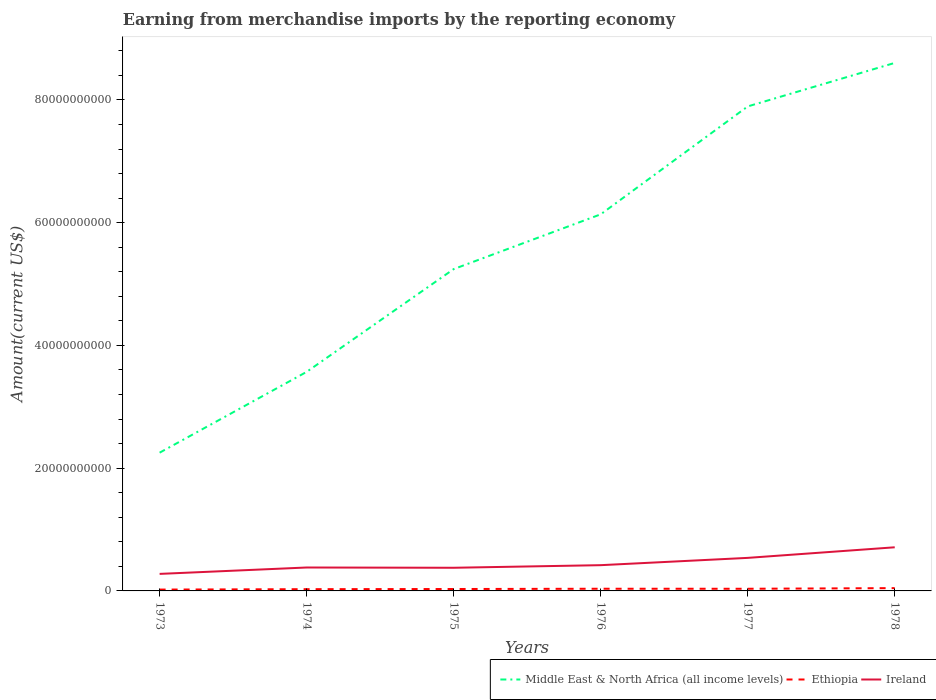Across all years, what is the maximum amount earned from merchandise imports in Ireland?
Your answer should be very brief. 2.78e+09. What is the total amount earned from merchandise imports in Ethiopia in the graph?
Give a very brief answer. -2.67e+07. What is the difference between the highest and the second highest amount earned from merchandise imports in Ethiopia?
Offer a very short reply. 2.37e+08. What is the difference between the highest and the lowest amount earned from merchandise imports in Middle East & North Africa (all income levels)?
Ensure brevity in your answer.  3. Are the values on the major ticks of Y-axis written in scientific E-notation?
Offer a terse response. No. Does the graph contain any zero values?
Your answer should be compact. No. Does the graph contain grids?
Give a very brief answer. No. What is the title of the graph?
Ensure brevity in your answer.  Earning from merchandise imports by the reporting economy. What is the label or title of the Y-axis?
Make the answer very short. Amount(current US$). What is the Amount(current US$) of Middle East & North Africa (all income levels) in 1973?
Offer a very short reply. 2.25e+1. What is the Amount(current US$) of Ethiopia in 1973?
Make the answer very short. 2.18e+08. What is the Amount(current US$) in Ireland in 1973?
Your answer should be compact. 2.78e+09. What is the Amount(current US$) in Middle East & North Africa (all income levels) in 1974?
Your response must be concise. 3.57e+1. What is the Amount(current US$) in Ethiopia in 1974?
Offer a very short reply. 2.84e+08. What is the Amount(current US$) of Ireland in 1974?
Your response must be concise. 3.82e+09. What is the Amount(current US$) of Middle East & North Africa (all income levels) in 1975?
Your answer should be very brief. 5.24e+1. What is the Amount(current US$) in Ethiopia in 1975?
Your response must be concise. 3.11e+08. What is the Amount(current US$) of Ireland in 1975?
Provide a short and direct response. 3.77e+09. What is the Amount(current US$) in Middle East & North Africa (all income levels) in 1976?
Provide a succinct answer. 6.14e+1. What is the Amount(current US$) of Ethiopia in 1976?
Your answer should be compact. 3.55e+08. What is the Amount(current US$) in Ireland in 1976?
Offer a terse response. 4.20e+09. What is the Amount(current US$) of Middle East & North Africa (all income levels) in 1977?
Your answer should be compact. 7.89e+1. What is the Amount(current US$) in Ethiopia in 1977?
Your answer should be very brief. 3.52e+08. What is the Amount(current US$) of Ireland in 1977?
Your answer should be very brief. 5.38e+09. What is the Amount(current US$) in Middle East & North Africa (all income levels) in 1978?
Your answer should be compact. 8.60e+1. What is the Amount(current US$) in Ethiopia in 1978?
Provide a short and direct response. 4.55e+08. What is the Amount(current US$) in Ireland in 1978?
Make the answer very short. 7.11e+09. Across all years, what is the maximum Amount(current US$) of Middle East & North Africa (all income levels)?
Your answer should be compact. 8.60e+1. Across all years, what is the maximum Amount(current US$) of Ethiopia?
Your answer should be compact. 4.55e+08. Across all years, what is the maximum Amount(current US$) in Ireland?
Make the answer very short. 7.11e+09. Across all years, what is the minimum Amount(current US$) in Middle East & North Africa (all income levels)?
Provide a short and direct response. 2.25e+1. Across all years, what is the minimum Amount(current US$) in Ethiopia?
Your response must be concise. 2.18e+08. Across all years, what is the minimum Amount(current US$) of Ireland?
Offer a terse response. 2.78e+09. What is the total Amount(current US$) in Middle East & North Africa (all income levels) in the graph?
Your answer should be compact. 3.37e+11. What is the total Amount(current US$) of Ethiopia in the graph?
Your response must be concise. 1.98e+09. What is the total Amount(current US$) of Ireland in the graph?
Offer a terse response. 2.71e+1. What is the difference between the Amount(current US$) of Middle East & North Africa (all income levels) in 1973 and that in 1974?
Keep it short and to the point. -1.32e+1. What is the difference between the Amount(current US$) in Ethiopia in 1973 and that in 1974?
Keep it short and to the point. -6.57e+07. What is the difference between the Amount(current US$) in Ireland in 1973 and that in 1974?
Ensure brevity in your answer.  -1.04e+09. What is the difference between the Amount(current US$) of Middle East & North Africa (all income levels) in 1973 and that in 1975?
Keep it short and to the point. -2.99e+1. What is the difference between the Amount(current US$) of Ethiopia in 1973 and that in 1975?
Provide a succinct answer. -9.24e+07. What is the difference between the Amount(current US$) in Ireland in 1973 and that in 1975?
Keep it short and to the point. -9.96e+08. What is the difference between the Amount(current US$) of Middle East & North Africa (all income levels) in 1973 and that in 1976?
Keep it short and to the point. -3.88e+1. What is the difference between the Amount(current US$) of Ethiopia in 1973 and that in 1976?
Offer a terse response. -1.37e+08. What is the difference between the Amount(current US$) in Ireland in 1973 and that in 1976?
Your response must be concise. -1.42e+09. What is the difference between the Amount(current US$) of Middle East & North Africa (all income levels) in 1973 and that in 1977?
Your answer should be compact. -5.64e+1. What is the difference between the Amount(current US$) in Ethiopia in 1973 and that in 1977?
Keep it short and to the point. -1.33e+08. What is the difference between the Amount(current US$) of Ireland in 1973 and that in 1977?
Your answer should be very brief. -2.61e+09. What is the difference between the Amount(current US$) of Middle East & North Africa (all income levels) in 1973 and that in 1978?
Your answer should be very brief. -6.35e+1. What is the difference between the Amount(current US$) in Ethiopia in 1973 and that in 1978?
Provide a short and direct response. -2.37e+08. What is the difference between the Amount(current US$) in Ireland in 1973 and that in 1978?
Offer a very short reply. -4.33e+09. What is the difference between the Amount(current US$) of Middle East & North Africa (all income levels) in 1974 and that in 1975?
Your response must be concise. -1.67e+1. What is the difference between the Amount(current US$) of Ethiopia in 1974 and that in 1975?
Offer a terse response. -2.67e+07. What is the difference between the Amount(current US$) in Ireland in 1974 and that in 1975?
Offer a very short reply. 4.50e+07. What is the difference between the Amount(current US$) of Middle East & North Africa (all income levels) in 1974 and that in 1976?
Provide a short and direct response. -2.57e+1. What is the difference between the Amount(current US$) of Ethiopia in 1974 and that in 1976?
Ensure brevity in your answer.  -7.11e+07. What is the difference between the Amount(current US$) in Ireland in 1974 and that in 1976?
Make the answer very short. -3.78e+08. What is the difference between the Amount(current US$) of Middle East & North Africa (all income levels) in 1974 and that in 1977?
Make the answer very short. -4.33e+1. What is the difference between the Amount(current US$) in Ethiopia in 1974 and that in 1977?
Give a very brief answer. -6.75e+07. What is the difference between the Amount(current US$) of Ireland in 1974 and that in 1977?
Your answer should be compact. -1.57e+09. What is the difference between the Amount(current US$) in Middle East & North Africa (all income levels) in 1974 and that in 1978?
Make the answer very short. -5.03e+1. What is the difference between the Amount(current US$) in Ethiopia in 1974 and that in 1978?
Your answer should be compact. -1.71e+08. What is the difference between the Amount(current US$) in Ireland in 1974 and that in 1978?
Provide a short and direct response. -3.29e+09. What is the difference between the Amount(current US$) in Middle East & North Africa (all income levels) in 1975 and that in 1976?
Your answer should be compact. -8.92e+09. What is the difference between the Amount(current US$) of Ethiopia in 1975 and that in 1976?
Offer a very short reply. -4.44e+07. What is the difference between the Amount(current US$) in Ireland in 1975 and that in 1976?
Your answer should be compact. -4.23e+08. What is the difference between the Amount(current US$) of Middle East & North Africa (all income levels) in 1975 and that in 1977?
Offer a very short reply. -2.65e+1. What is the difference between the Amount(current US$) of Ethiopia in 1975 and that in 1977?
Your answer should be very brief. -4.08e+07. What is the difference between the Amount(current US$) of Ireland in 1975 and that in 1977?
Your answer should be compact. -1.61e+09. What is the difference between the Amount(current US$) in Middle East & North Africa (all income levels) in 1975 and that in 1978?
Your answer should be very brief. -3.36e+1. What is the difference between the Amount(current US$) in Ethiopia in 1975 and that in 1978?
Your answer should be very brief. -1.45e+08. What is the difference between the Amount(current US$) of Ireland in 1975 and that in 1978?
Ensure brevity in your answer.  -3.34e+09. What is the difference between the Amount(current US$) of Middle East & North Africa (all income levels) in 1976 and that in 1977?
Your response must be concise. -1.76e+1. What is the difference between the Amount(current US$) of Ethiopia in 1976 and that in 1977?
Your answer should be compact. 3.63e+06. What is the difference between the Amount(current US$) in Ireland in 1976 and that in 1977?
Provide a succinct answer. -1.19e+09. What is the difference between the Amount(current US$) of Middle East & North Africa (all income levels) in 1976 and that in 1978?
Your answer should be compact. -2.47e+1. What is the difference between the Amount(current US$) of Ethiopia in 1976 and that in 1978?
Your answer should be very brief. -1.00e+08. What is the difference between the Amount(current US$) of Ireland in 1976 and that in 1978?
Your answer should be compact. -2.91e+09. What is the difference between the Amount(current US$) in Middle East & North Africa (all income levels) in 1977 and that in 1978?
Provide a succinct answer. -7.09e+09. What is the difference between the Amount(current US$) of Ethiopia in 1977 and that in 1978?
Your answer should be compact. -1.04e+08. What is the difference between the Amount(current US$) of Ireland in 1977 and that in 1978?
Provide a short and direct response. -1.73e+09. What is the difference between the Amount(current US$) of Middle East & North Africa (all income levels) in 1973 and the Amount(current US$) of Ethiopia in 1974?
Give a very brief answer. 2.22e+1. What is the difference between the Amount(current US$) of Middle East & North Africa (all income levels) in 1973 and the Amount(current US$) of Ireland in 1974?
Offer a very short reply. 1.87e+1. What is the difference between the Amount(current US$) of Ethiopia in 1973 and the Amount(current US$) of Ireland in 1974?
Offer a terse response. -3.60e+09. What is the difference between the Amount(current US$) of Middle East & North Africa (all income levels) in 1973 and the Amount(current US$) of Ethiopia in 1975?
Provide a succinct answer. 2.22e+1. What is the difference between the Amount(current US$) in Middle East & North Africa (all income levels) in 1973 and the Amount(current US$) in Ireland in 1975?
Your answer should be compact. 1.88e+1. What is the difference between the Amount(current US$) of Ethiopia in 1973 and the Amount(current US$) of Ireland in 1975?
Provide a short and direct response. -3.55e+09. What is the difference between the Amount(current US$) in Middle East & North Africa (all income levels) in 1973 and the Amount(current US$) in Ethiopia in 1976?
Keep it short and to the point. 2.22e+1. What is the difference between the Amount(current US$) of Middle East & North Africa (all income levels) in 1973 and the Amount(current US$) of Ireland in 1976?
Provide a short and direct response. 1.83e+1. What is the difference between the Amount(current US$) of Ethiopia in 1973 and the Amount(current US$) of Ireland in 1976?
Your response must be concise. -3.98e+09. What is the difference between the Amount(current US$) in Middle East & North Africa (all income levels) in 1973 and the Amount(current US$) in Ethiopia in 1977?
Offer a terse response. 2.22e+1. What is the difference between the Amount(current US$) of Middle East & North Africa (all income levels) in 1973 and the Amount(current US$) of Ireland in 1977?
Keep it short and to the point. 1.71e+1. What is the difference between the Amount(current US$) in Ethiopia in 1973 and the Amount(current US$) in Ireland in 1977?
Your response must be concise. -5.17e+09. What is the difference between the Amount(current US$) in Middle East & North Africa (all income levels) in 1973 and the Amount(current US$) in Ethiopia in 1978?
Offer a terse response. 2.21e+1. What is the difference between the Amount(current US$) in Middle East & North Africa (all income levels) in 1973 and the Amount(current US$) in Ireland in 1978?
Your response must be concise. 1.54e+1. What is the difference between the Amount(current US$) of Ethiopia in 1973 and the Amount(current US$) of Ireland in 1978?
Your response must be concise. -6.89e+09. What is the difference between the Amount(current US$) in Middle East & North Africa (all income levels) in 1974 and the Amount(current US$) in Ethiopia in 1975?
Your answer should be compact. 3.54e+1. What is the difference between the Amount(current US$) of Middle East & North Africa (all income levels) in 1974 and the Amount(current US$) of Ireland in 1975?
Give a very brief answer. 3.19e+1. What is the difference between the Amount(current US$) in Ethiopia in 1974 and the Amount(current US$) in Ireland in 1975?
Ensure brevity in your answer.  -3.49e+09. What is the difference between the Amount(current US$) in Middle East & North Africa (all income levels) in 1974 and the Amount(current US$) in Ethiopia in 1976?
Your answer should be compact. 3.53e+1. What is the difference between the Amount(current US$) of Middle East & North Africa (all income levels) in 1974 and the Amount(current US$) of Ireland in 1976?
Your response must be concise. 3.15e+1. What is the difference between the Amount(current US$) in Ethiopia in 1974 and the Amount(current US$) in Ireland in 1976?
Give a very brief answer. -3.91e+09. What is the difference between the Amount(current US$) in Middle East & North Africa (all income levels) in 1974 and the Amount(current US$) in Ethiopia in 1977?
Offer a very short reply. 3.53e+1. What is the difference between the Amount(current US$) in Middle East & North Africa (all income levels) in 1974 and the Amount(current US$) in Ireland in 1977?
Keep it short and to the point. 3.03e+1. What is the difference between the Amount(current US$) in Ethiopia in 1974 and the Amount(current US$) in Ireland in 1977?
Provide a succinct answer. -5.10e+09. What is the difference between the Amount(current US$) of Middle East & North Africa (all income levels) in 1974 and the Amount(current US$) of Ethiopia in 1978?
Make the answer very short. 3.52e+1. What is the difference between the Amount(current US$) of Middle East & North Africa (all income levels) in 1974 and the Amount(current US$) of Ireland in 1978?
Your answer should be compact. 2.86e+1. What is the difference between the Amount(current US$) in Ethiopia in 1974 and the Amount(current US$) in Ireland in 1978?
Give a very brief answer. -6.83e+09. What is the difference between the Amount(current US$) in Middle East & North Africa (all income levels) in 1975 and the Amount(current US$) in Ethiopia in 1976?
Your answer should be compact. 5.21e+1. What is the difference between the Amount(current US$) in Middle East & North Africa (all income levels) in 1975 and the Amount(current US$) in Ireland in 1976?
Offer a terse response. 4.82e+1. What is the difference between the Amount(current US$) of Ethiopia in 1975 and the Amount(current US$) of Ireland in 1976?
Your response must be concise. -3.88e+09. What is the difference between the Amount(current US$) in Middle East & North Africa (all income levels) in 1975 and the Amount(current US$) in Ethiopia in 1977?
Ensure brevity in your answer.  5.21e+1. What is the difference between the Amount(current US$) in Middle East & North Africa (all income levels) in 1975 and the Amount(current US$) in Ireland in 1977?
Offer a terse response. 4.71e+1. What is the difference between the Amount(current US$) of Ethiopia in 1975 and the Amount(current US$) of Ireland in 1977?
Your answer should be very brief. -5.07e+09. What is the difference between the Amount(current US$) in Middle East & North Africa (all income levels) in 1975 and the Amount(current US$) in Ethiopia in 1978?
Provide a short and direct response. 5.20e+1. What is the difference between the Amount(current US$) of Middle East & North Africa (all income levels) in 1975 and the Amount(current US$) of Ireland in 1978?
Give a very brief answer. 4.53e+1. What is the difference between the Amount(current US$) in Ethiopia in 1975 and the Amount(current US$) in Ireland in 1978?
Provide a short and direct response. -6.80e+09. What is the difference between the Amount(current US$) in Middle East & North Africa (all income levels) in 1976 and the Amount(current US$) in Ethiopia in 1977?
Provide a succinct answer. 6.10e+1. What is the difference between the Amount(current US$) of Middle East & North Africa (all income levels) in 1976 and the Amount(current US$) of Ireland in 1977?
Your response must be concise. 5.60e+1. What is the difference between the Amount(current US$) in Ethiopia in 1976 and the Amount(current US$) in Ireland in 1977?
Your response must be concise. -5.03e+09. What is the difference between the Amount(current US$) of Middle East & North Africa (all income levels) in 1976 and the Amount(current US$) of Ethiopia in 1978?
Keep it short and to the point. 6.09e+1. What is the difference between the Amount(current US$) in Middle East & North Africa (all income levels) in 1976 and the Amount(current US$) in Ireland in 1978?
Make the answer very short. 5.43e+1. What is the difference between the Amount(current US$) in Ethiopia in 1976 and the Amount(current US$) in Ireland in 1978?
Your response must be concise. -6.75e+09. What is the difference between the Amount(current US$) of Middle East & North Africa (all income levels) in 1977 and the Amount(current US$) of Ethiopia in 1978?
Provide a short and direct response. 7.85e+1. What is the difference between the Amount(current US$) in Middle East & North Africa (all income levels) in 1977 and the Amount(current US$) in Ireland in 1978?
Your answer should be very brief. 7.18e+1. What is the difference between the Amount(current US$) in Ethiopia in 1977 and the Amount(current US$) in Ireland in 1978?
Your response must be concise. -6.76e+09. What is the average Amount(current US$) of Middle East & North Africa (all income levels) per year?
Offer a terse response. 5.62e+1. What is the average Amount(current US$) of Ethiopia per year?
Your answer should be very brief. 3.29e+08. What is the average Amount(current US$) in Ireland per year?
Your answer should be very brief. 4.51e+09. In the year 1973, what is the difference between the Amount(current US$) in Middle East & North Africa (all income levels) and Amount(current US$) in Ethiopia?
Ensure brevity in your answer.  2.23e+1. In the year 1973, what is the difference between the Amount(current US$) in Middle East & North Africa (all income levels) and Amount(current US$) in Ireland?
Make the answer very short. 1.97e+1. In the year 1973, what is the difference between the Amount(current US$) of Ethiopia and Amount(current US$) of Ireland?
Ensure brevity in your answer.  -2.56e+09. In the year 1974, what is the difference between the Amount(current US$) in Middle East & North Africa (all income levels) and Amount(current US$) in Ethiopia?
Make the answer very short. 3.54e+1. In the year 1974, what is the difference between the Amount(current US$) of Middle East & North Africa (all income levels) and Amount(current US$) of Ireland?
Provide a succinct answer. 3.19e+1. In the year 1974, what is the difference between the Amount(current US$) of Ethiopia and Amount(current US$) of Ireland?
Provide a short and direct response. -3.53e+09. In the year 1975, what is the difference between the Amount(current US$) in Middle East & North Africa (all income levels) and Amount(current US$) in Ethiopia?
Provide a succinct answer. 5.21e+1. In the year 1975, what is the difference between the Amount(current US$) of Middle East & North Africa (all income levels) and Amount(current US$) of Ireland?
Your answer should be compact. 4.87e+1. In the year 1975, what is the difference between the Amount(current US$) of Ethiopia and Amount(current US$) of Ireland?
Keep it short and to the point. -3.46e+09. In the year 1976, what is the difference between the Amount(current US$) in Middle East & North Africa (all income levels) and Amount(current US$) in Ethiopia?
Offer a terse response. 6.10e+1. In the year 1976, what is the difference between the Amount(current US$) of Middle East & North Africa (all income levels) and Amount(current US$) of Ireland?
Offer a terse response. 5.72e+1. In the year 1976, what is the difference between the Amount(current US$) in Ethiopia and Amount(current US$) in Ireland?
Make the answer very short. -3.84e+09. In the year 1977, what is the difference between the Amount(current US$) in Middle East & North Africa (all income levels) and Amount(current US$) in Ethiopia?
Your answer should be very brief. 7.86e+1. In the year 1977, what is the difference between the Amount(current US$) of Middle East & North Africa (all income levels) and Amount(current US$) of Ireland?
Provide a short and direct response. 7.36e+1. In the year 1977, what is the difference between the Amount(current US$) of Ethiopia and Amount(current US$) of Ireland?
Provide a succinct answer. -5.03e+09. In the year 1978, what is the difference between the Amount(current US$) of Middle East & North Africa (all income levels) and Amount(current US$) of Ethiopia?
Your answer should be very brief. 8.56e+1. In the year 1978, what is the difference between the Amount(current US$) of Middle East & North Africa (all income levels) and Amount(current US$) of Ireland?
Your response must be concise. 7.89e+1. In the year 1978, what is the difference between the Amount(current US$) of Ethiopia and Amount(current US$) of Ireland?
Ensure brevity in your answer.  -6.65e+09. What is the ratio of the Amount(current US$) of Middle East & North Africa (all income levels) in 1973 to that in 1974?
Make the answer very short. 0.63. What is the ratio of the Amount(current US$) in Ethiopia in 1973 to that in 1974?
Make the answer very short. 0.77. What is the ratio of the Amount(current US$) in Ireland in 1973 to that in 1974?
Your response must be concise. 0.73. What is the ratio of the Amount(current US$) in Middle East & North Africa (all income levels) in 1973 to that in 1975?
Provide a succinct answer. 0.43. What is the ratio of the Amount(current US$) in Ethiopia in 1973 to that in 1975?
Provide a succinct answer. 0.7. What is the ratio of the Amount(current US$) in Ireland in 1973 to that in 1975?
Make the answer very short. 0.74. What is the ratio of the Amount(current US$) in Middle East & North Africa (all income levels) in 1973 to that in 1976?
Your response must be concise. 0.37. What is the ratio of the Amount(current US$) in Ethiopia in 1973 to that in 1976?
Offer a very short reply. 0.61. What is the ratio of the Amount(current US$) in Ireland in 1973 to that in 1976?
Give a very brief answer. 0.66. What is the ratio of the Amount(current US$) in Middle East & North Africa (all income levels) in 1973 to that in 1977?
Your answer should be compact. 0.29. What is the ratio of the Amount(current US$) of Ethiopia in 1973 to that in 1977?
Ensure brevity in your answer.  0.62. What is the ratio of the Amount(current US$) in Ireland in 1973 to that in 1977?
Offer a very short reply. 0.52. What is the ratio of the Amount(current US$) of Middle East & North Africa (all income levels) in 1973 to that in 1978?
Offer a terse response. 0.26. What is the ratio of the Amount(current US$) in Ethiopia in 1973 to that in 1978?
Ensure brevity in your answer.  0.48. What is the ratio of the Amount(current US$) in Ireland in 1973 to that in 1978?
Your answer should be very brief. 0.39. What is the ratio of the Amount(current US$) in Middle East & North Africa (all income levels) in 1974 to that in 1975?
Provide a short and direct response. 0.68. What is the ratio of the Amount(current US$) of Ethiopia in 1974 to that in 1975?
Your response must be concise. 0.91. What is the ratio of the Amount(current US$) in Ireland in 1974 to that in 1975?
Provide a short and direct response. 1.01. What is the ratio of the Amount(current US$) in Middle East & North Africa (all income levels) in 1974 to that in 1976?
Give a very brief answer. 0.58. What is the ratio of the Amount(current US$) in Ethiopia in 1974 to that in 1976?
Offer a terse response. 0.8. What is the ratio of the Amount(current US$) in Ireland in 1974 to that in 1976?
Provide a succinct answer. 0.91. What is the ratio of the Amount(current US$) in Middle East & North Africa (all income levels) in 1974 to that in 1977?
Keep it short and to the point. 0.45. What is the ratio of the Amount(current US$) of Ethiopia in 1974 to that in 1977?
Provide a succinct answer. 0.81. What is the ratio of the Amount(current US$) in Ireland in 1974 to that in 1977?
Provide a short and direct response. 0.71. What is the ratio of the Amount(current US$) of Middle East & North Africa (all income levels) in 1974 to that in 1978?
Give a very brief answer. 0.41. What is the ratio of the Amount(current US$) in Ethiopia in 1974 to that in 1978?
Make the answer very short. 0.62. What is the ratio of the Amount(current US$) of Ireland in 1974 to that in 1978?
Offer a very short reply. 0.54. What is the ratio of the Amount(current US$) in Middle East & North Africa (all income levels) in 1975 to that in 1976?
Provide a succinct answer. 0.85. What is the ratio of the Amount(current US$) of Ethiopia in 1975 to that in 1976?
Make the answer very short. 0.87. What is the ratio of the Amount(current US$) in Ireland in 1975 to that in 1976?
Offer a terse response. 0.9. What is the ratio of the Amount(current US$) in Middle East & North Africa (all income levels) in 1975 to that in 1977?
Provide a short and direct response. 0.66. What is the ratio of the Amount(current US$) of Ethiopia in 1975 to that in 1977?
Offer a terse response. 0.88. What is the ratio of the Amount(current US$) of Ireland in 1975 to that in 1977?
Give a very brief answer. 0.7. What is the ratio of the Amount(current US$) in Middle East & North Africa (all income levels) in 1975 to that in 1978?
Your answer should be very brief. 0.61. What is the ratio of the Amount(current US$) in Ethiopia in 1975 to that in 1978?
Ensure brevity in your answer.  0.68. What is the ratio of the Amount(current US$) of Ireland in 1975 to that in 1978?
Offer a very short reply. 0.53. What is the ratio of the Amount(current US$) in Middle East & North Africa (all income levels) in 1976 to that in 1977?
Provide a succinct answer. 0.78. What is the ratio of the Amount(current US$) of Ethiopia in 1976 to that in 1977?
Provide a short and direct response. 1.01. What is the ratio of the Amount(current US$) of Ireland in 1976 to that in 1977?
Your answer should be very brief. 0.78. What is the ratio of the Amount(current US$) of Middle East & North Africa (all income levels) in 1976 to that in 1978?
Ensure brevity in your answer.  0.71. What is the ratio of the Amount(current US$) of Ethiopia in 1976 to that in 1978?
Give a very brief answer. 0.78. What is the ratio of the Amount(current US$) in Ireland in 1976 to that in 1978?
Offer a terse response. 0.59. What is the ratio of the Amount(current US$) of Middle East & North Africa (all income levels) in 1977 to that in 1978?
Offer a terse response. 0.92. What is the ratio of the Amount(current US$) of Ethiopia in 1977 to that in 1978?
Your answer should be very brief. 0.77. What is the ratio of the Amount(current US$) of Ireland in 1977 to that in 1978?
Provide a succinct answer. 0.76. What is the difference between the highest and the second highest Amount(current US$) of Middle East & North Africa (all income levels)?
Keep it short and to the point. 7.09e+09. What is the difference between the highest and the second highest Amount(current US$) of Ethiopia?
Your answer should be very brief. 1.00e+08. What is the difference between the highest and the second highest Amount(current US$) of Ireland?
Offer a terse response. 1.73e+09. What is the difference between the highest and the lowest Amount(current US$) in Middle East & North Africa (all income levels)?
Keep it short and to the point. 6.35e+1. What is the difference between the highest and the lowest Amount(current US$) in Ethiopia?
Offer a terse response. 2.37e+08. What is the difference between the highest and the lowest Amount(current US$) of Ireland?
Provide a short and direct response. 4.33e+09. 